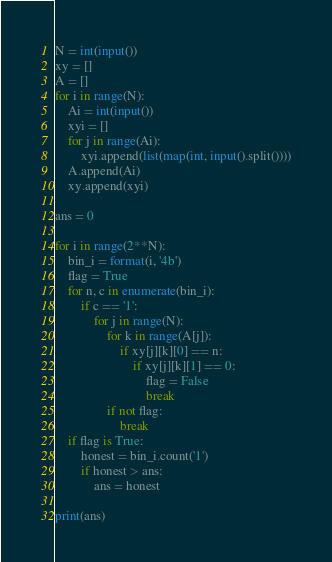Convert code to text. <code><loc_0><loc_0><loc_500><loc_500><_Python_>N = int(input())
xy = []
A = []
for i in range(N):
    Ai = int(input())
    xyi = []
    for j in range(Ai):
        xyi.append(list(map(int, input().split())))
    A.append(Ai)
    xy.append(xyi)

ans = 0

for i in range(2**N):
    bin_i = format(i, '4b')
    flag = True
    for n, c in enumerate(bin_i):
        if c == '1':
            for j in range(N):
                for k in range(A[j]):
                    if xy[j][k][0] == n:
                        if xy[j][k][1] == 0:
                            flag = False
                            break
                if not flag:
                    break
    if flag is True:
        honest = bin_i.count('1')
        if honest > ans:
            ans = honest

print(ans)
</code> 